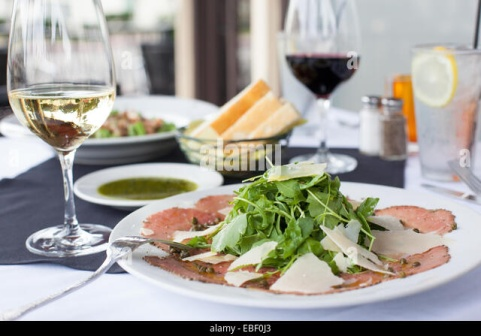How does the scene change if the setting is moved to a beachside restaurant? Relocating this scene to a beachside restaurant transforms the ambiance significantly. The gentle sound of waves lapping against the shore becomes the soundtrack of the meal as a soft, salty breeze wafts through the air. The tablecloth, now a light sandy hue, flutters slightly in the breeze, adding a casual elegance to the setting. Surrounding tables are dotted with seashells and small lanterns, casting a warm glow as the sun begins to set over the horizon, painting the sky in hues of pink and orange. The crisp white wine glistens in the twilight, mirroring the serene seascape. This new setting evokes a sense of tranquil leisure, where the diners can savor their meal while immersed in the natural beauty of the beachside. 